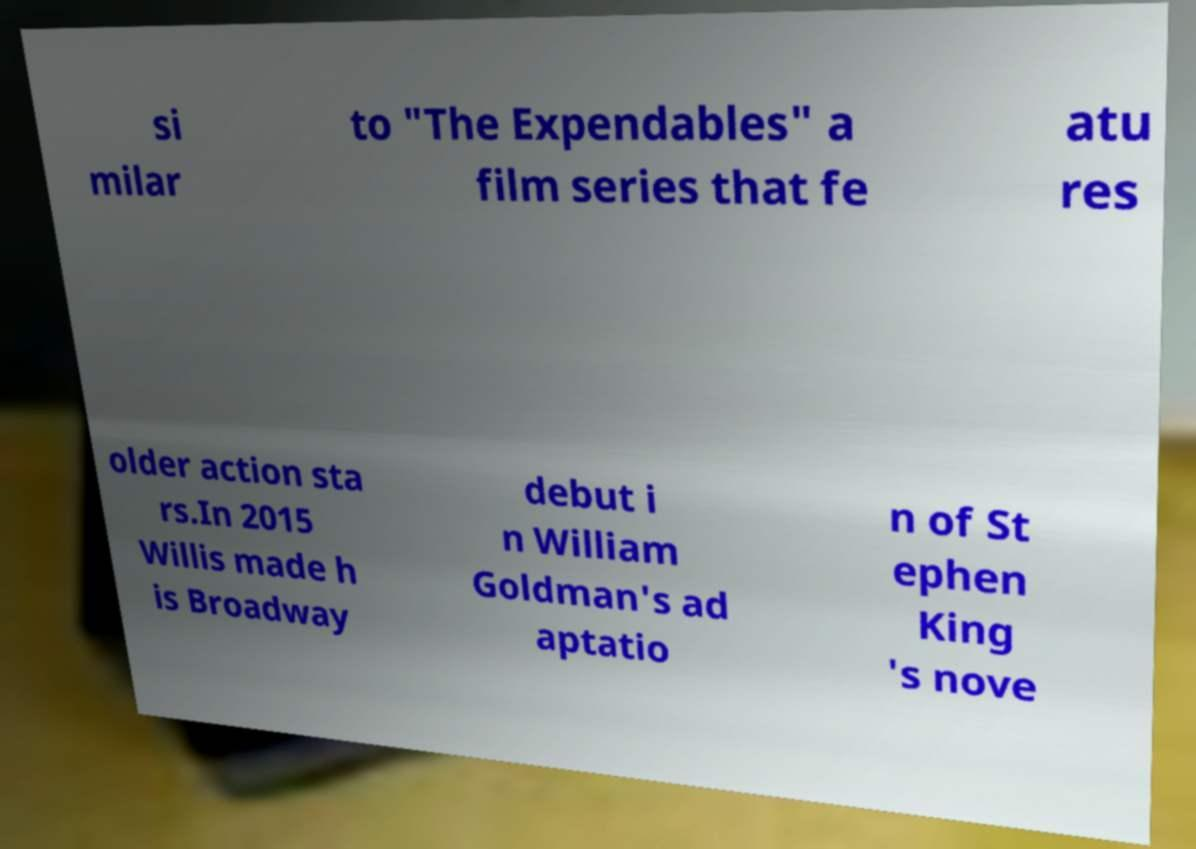I need the written content from this picture converted into text. Can you do that? si milar to "The Expendables" a film series that fe atu res older action sta rs.In 2015 Willis made h is Broadway debut i n William Goldman's ad aptatio n of St ephen King 's nove 